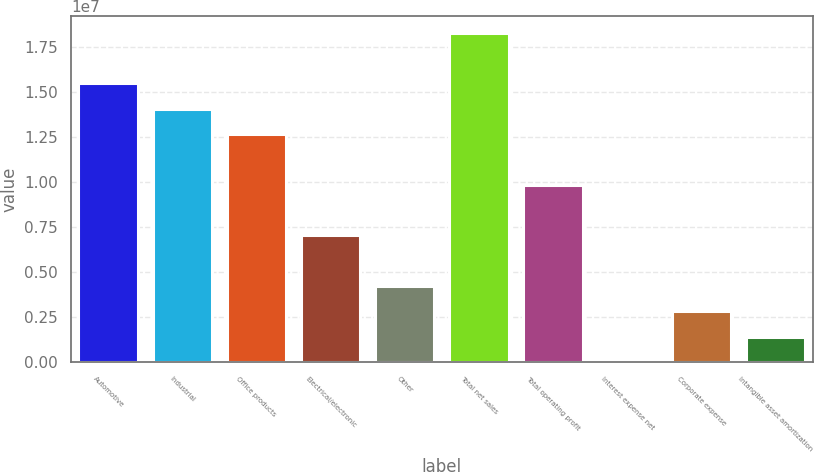Convert chart. <chart><loc_0><loc_0><loc_500><loc_500><bar_chart><fcel>Automotive<fcel>Industrial<fcel>Office products<fcel>Electrical/electronic<fcel>Other<fcel>Total net sales<fcel>Total operating profit<fcel>Interest expense net<fcel>Corporate expense<fcel>Intangible asset amortization<nl><fcel>1.54832e+07<fcel>1.40778e+07<fcel>1.26725e+07<fcel>7.05109e+06<fcel>4.24038e+06<fcel>1.82939e+07<fcel>9.86179e+06<fcel>24330<fcel>2.83503e+06<fcel>1.42968e+06<nl></chart> 